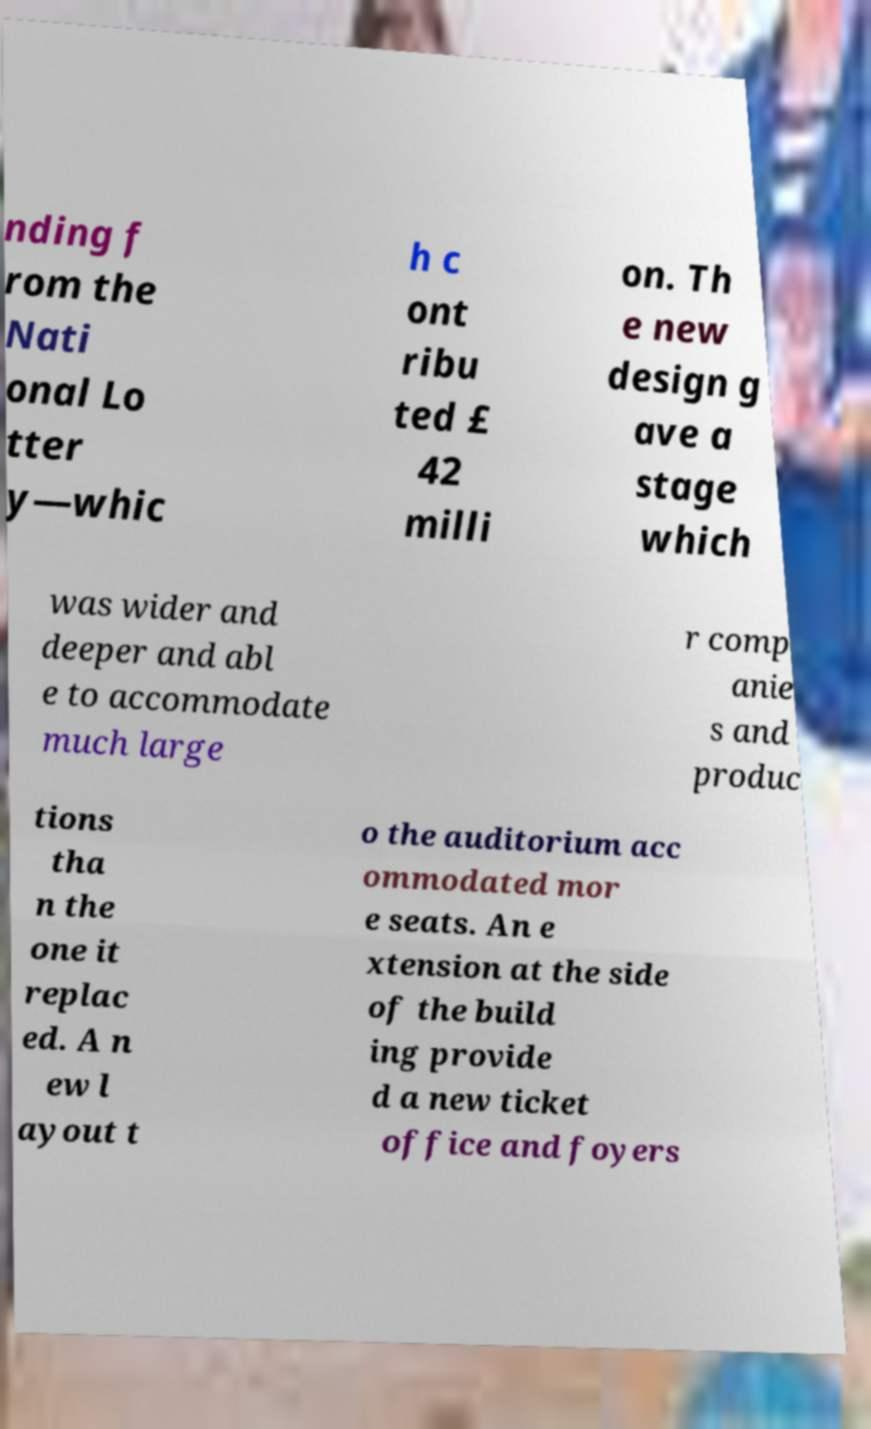Please read and relay the text visible in this image. What does it say? nding f rom the Nati onal Lo tter y—whic h c ont ribu ted £ 42 milli on. Th e new design g ave a stage which was wider and deeper and abl e to accommodate much large r comp anie s and produc tions tha n the one it replac ed. A n ew l ayout t o the auditorium acc ommodated mor e seats. An e xtension at the side of the build ing provide d a new ticket office and foyers 